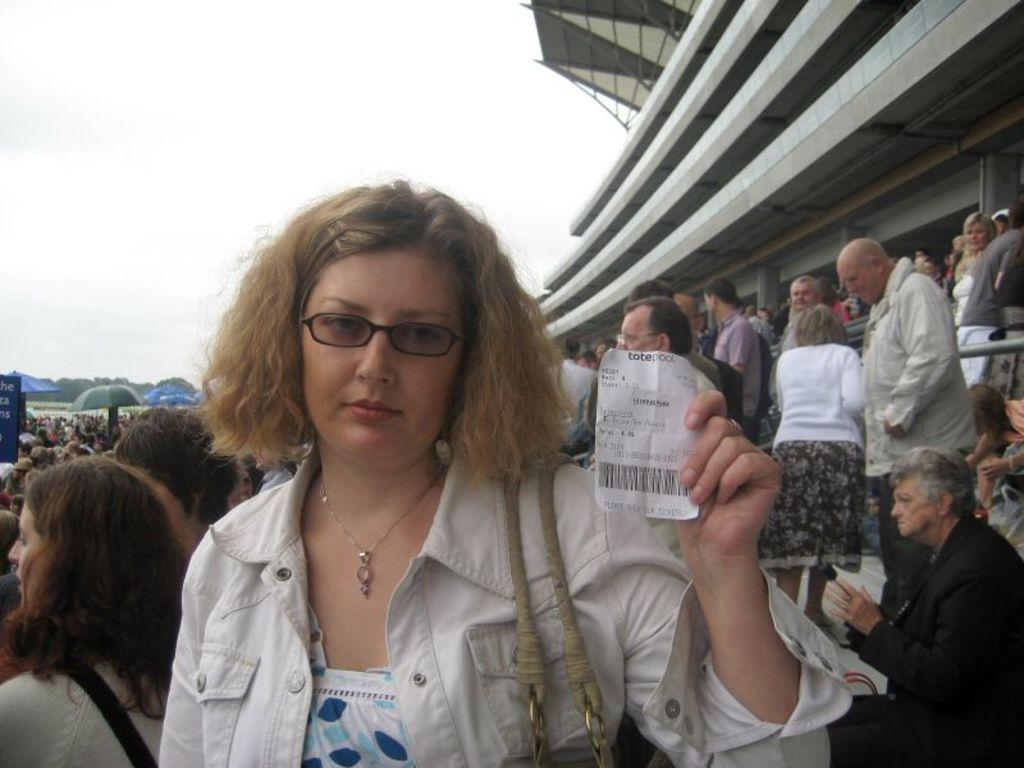What is the woman in the image holding with her hand? The woman is holding a paper with her hand. Can you describe the woman's appearance in the image? The woman is wearing spectacles. What can be seen in the background of the image? There is a crowd, at least one building, umbrellas, trees, and the sky visible in the background of the image. How many rabbits can be seen hopping around in the image? There are no rabbits present in the image. What type of insect is crawling on the woman's knee in the image? There is no insect visible on the woman's knee in the image. 